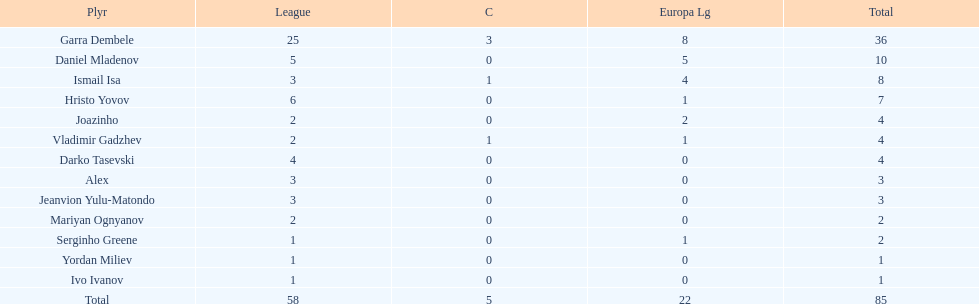Give me the full table as a dictionary. {'header': ['Plyr', 'League', 'C', 'Europa Lg', 'Total'], 'rows': [['Garra Dembele', '25', '3', '8', '36'], ['Daniel Mladenov', '5', '0', '5', '10'], ['Ismail Isa', '3', '1', '4', '8'], ['Hristo Yovov', '6', '0', '1', '7'], ['Joazinho', '2', '0', '2', '4'], ['Vladimir Gadzhev', '2', '1', '1', '4'], ['Darko Tasevski', '4', '0', '0', '4'], ['Alex', '3', '0', '0', '3'], ['Jeanvion Yulu-Matondo', '3', '0', '0', '3'], ['Mariyan Ognyanov', '2', '0', '0', '2'], ['Serginho Greene', '1', '0', '1', '2'], ['Yordan Miliev', '1', '0', '0', '1'], ['Ivo Ivanov', '1', '0', '0', '1'], ['Total', '58', '5', '22', '85']]} How many players had a total of 4? 3. 